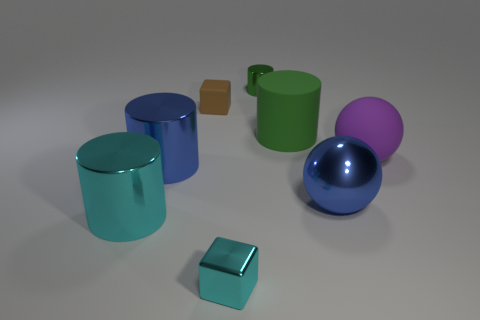There is a large metal thing to the right of the small thing in front of the large purple rubber object; what is its shape?
Make the answer very short. Sphere. How many objects are large matte cylinders or large blue objects that are on the right side of the big green object?
Your answer should be compact. 2. There is a large cylinder that is in front of the big blue object that is to the left of the small block behind the cyan metallic cylinder; what color is it?
Offer a very short reply. Cyan. There is a blue thing that is the same shape as the large cyan shiny thing; what is it made of?
Your answer should be compact. Metal. The metal sphere is what color?
Ensure brevity in your answer.  Blue. Does the big rubber cylinder have the same color as the tiny metallic cylinder?
Provide a succinct answer. Yes. How many metal things are large cyan things or small green spheres?
Your answer should be compact. 1. Is there a blue shiny cylinder to the right of the shiny thing that is on the right side of the tiny thing behind the brown object?
Your response must be concise. No. What is the size of the purple object that is the same material as the brown object?
Offer a very short reply. Large. There is a small cylinder; are there any cylinders right of it?
Offer a terse response. Yes. 